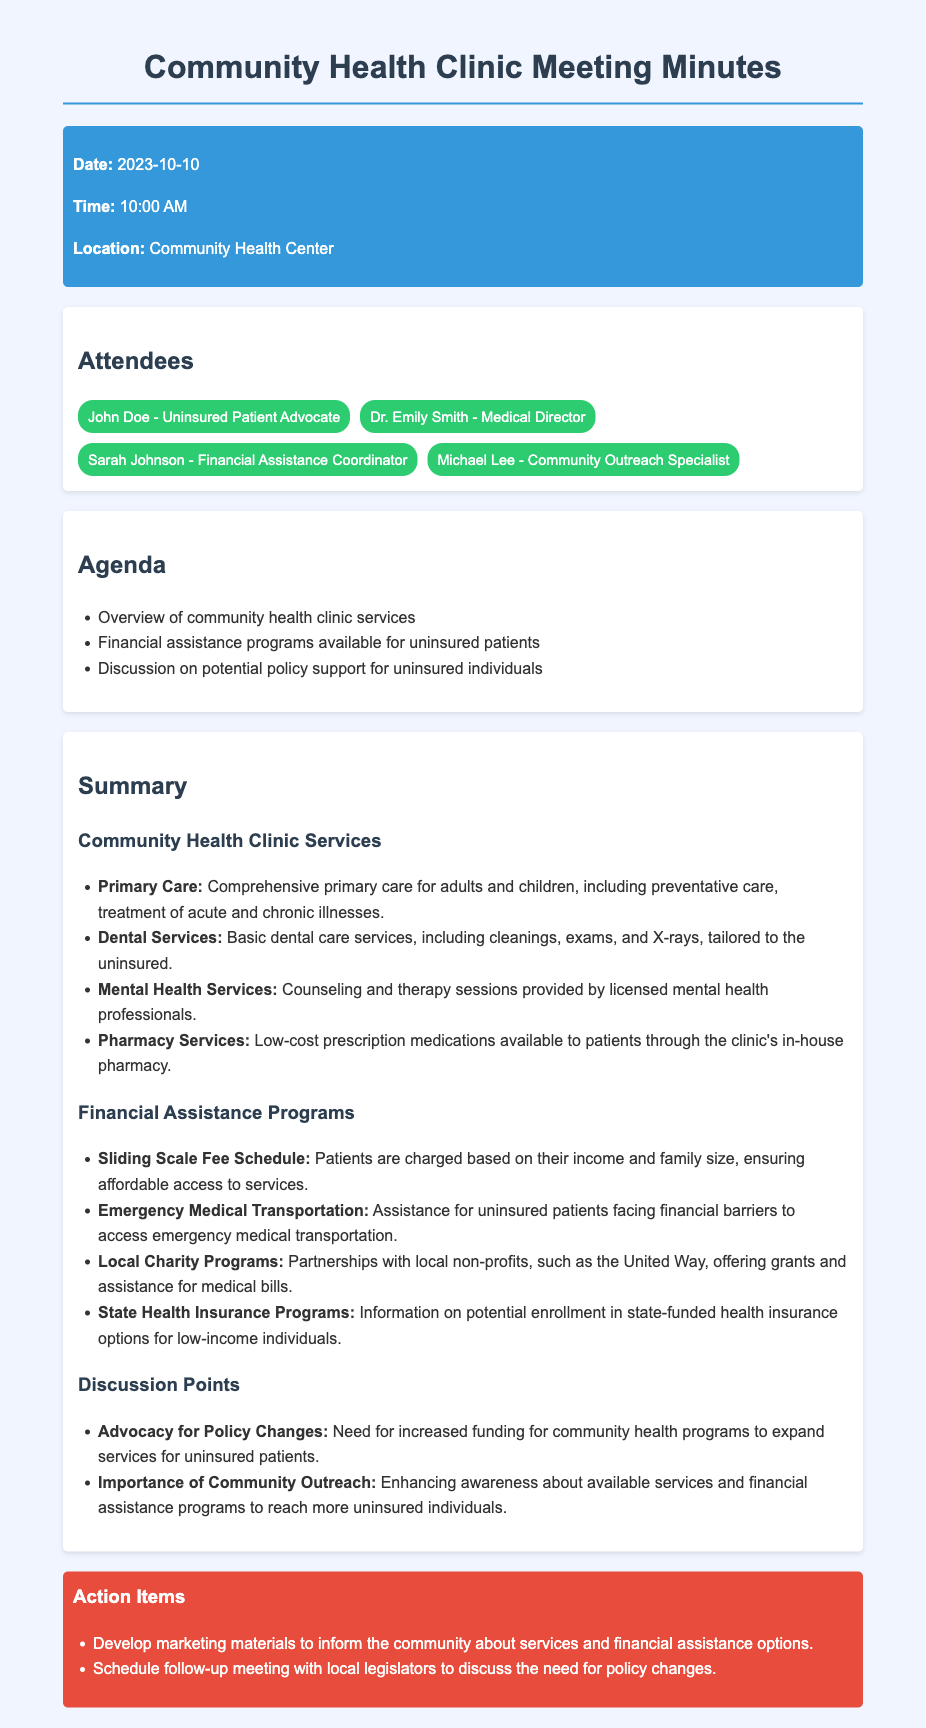What date was the meeting held? The meeting was held on the date specified in the header information of the document.
Answer: 2023-10-10 Who is the Financial Assistance Coordinator? The name of the Financial Assistance Coordinator is mentioned in the attendees section.
Answer: Sarah Johnson What services are included under Primary Care? The document outlines the services provided under Primary Care, which is highlighted in the summary section.
Answer: Comprehensive primary care for adults and children What is the purpose of the Sliding Scale Fee Schedule? The Sliding Scale Fee Schedule is designed to provide affordable access based on income, as stated in the financial assistance programs section.
Answer: Patients are charged based on their income and family size What key advocacy point was discussed concerning policy changes? The discussion point regarding advocacy for policy changes refers to enhancing funding for community health programs as highlighted in the document.
Answer: Increased funding for community health programs What type of assistance does the Emergency Medical Transportation program provide? The document specifies the assistance type offered under this program for uninsured patients.
Answer: Assistance for uninsured patients facing financial barriers How many attendees are listed in the minutes? The total count of attendees is specified in the attendees section.
Answer: Four What is one action item mentioned in the meeting minutes? The action items section lists specific actions decided during the meeting.
Answer: Develop marketing materials to inform the community 